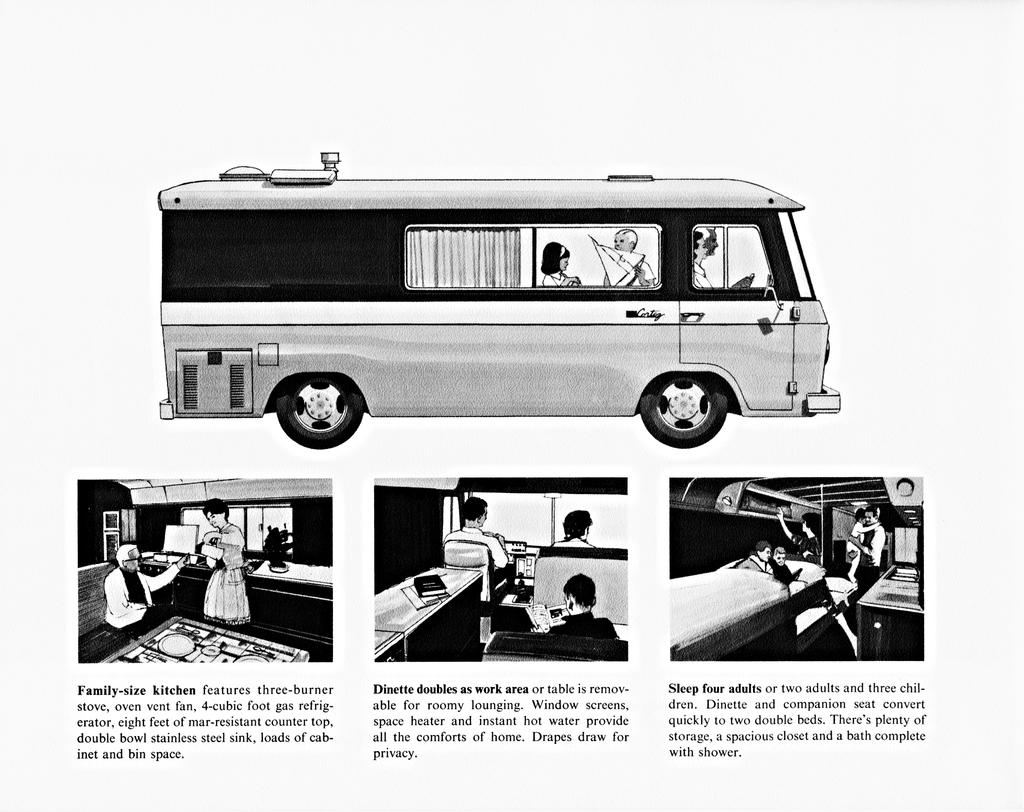Provide a one-sentence caption for the provided image. An advertisement for a trailer which features a family sized kitchen. 